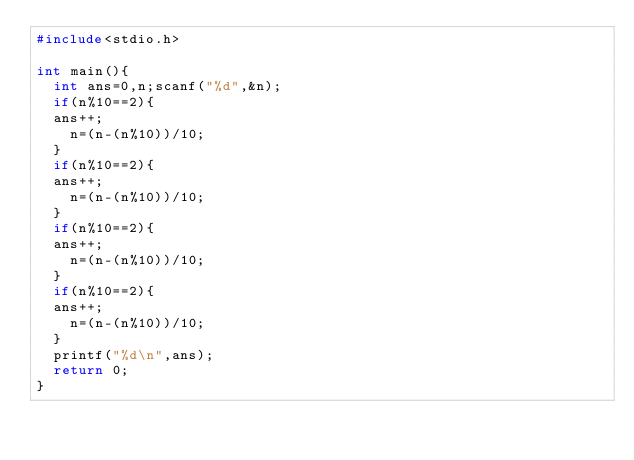<code> <loc_0><loc_0><loc_500><loc_500><_C_>#include<stdio.h>

int main(){
  int ans=0,n;scanf("%d",&n);
  if(n%10==2){
  ans++;
    n=(n-(n%10))/10;
  }
  if(n%10==2){
  ans++;
    n=(n-(n%10))/10;
  }
  if(n%10==2){
  ans++;
    n=(n-(n%10))/10;
  }
  if(n%10==2){
  ans++;
    n=(n-(n%10))/10;
  }
  printf("%d\n",ans);
  return 0;
}</code> 